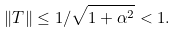<formula> <loc_0><loc_0><loc_500><loc_500>\| T \| \leq 1 / \sqrt { 1 + \alpha ^ { 2 } } < 1 .</formula> 